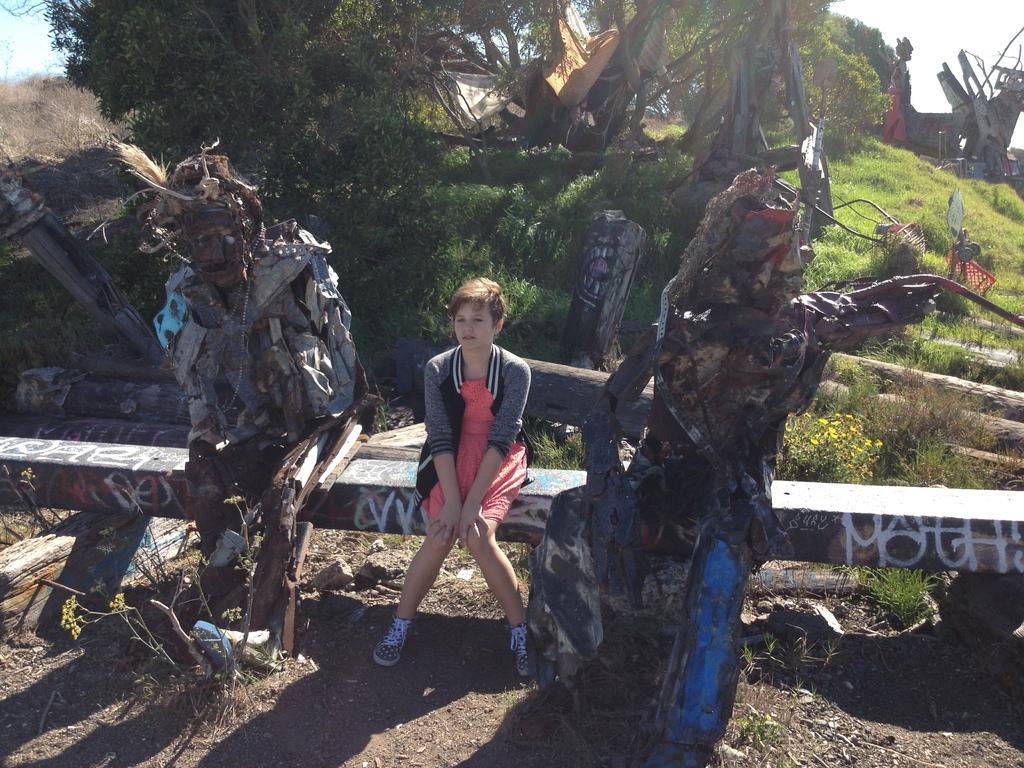Describe this image in one or two sentences. In this image we can see some statues and a person sitting on the pole, there are some trees, grass, wood and some other objects, in the background we can see the sky. 